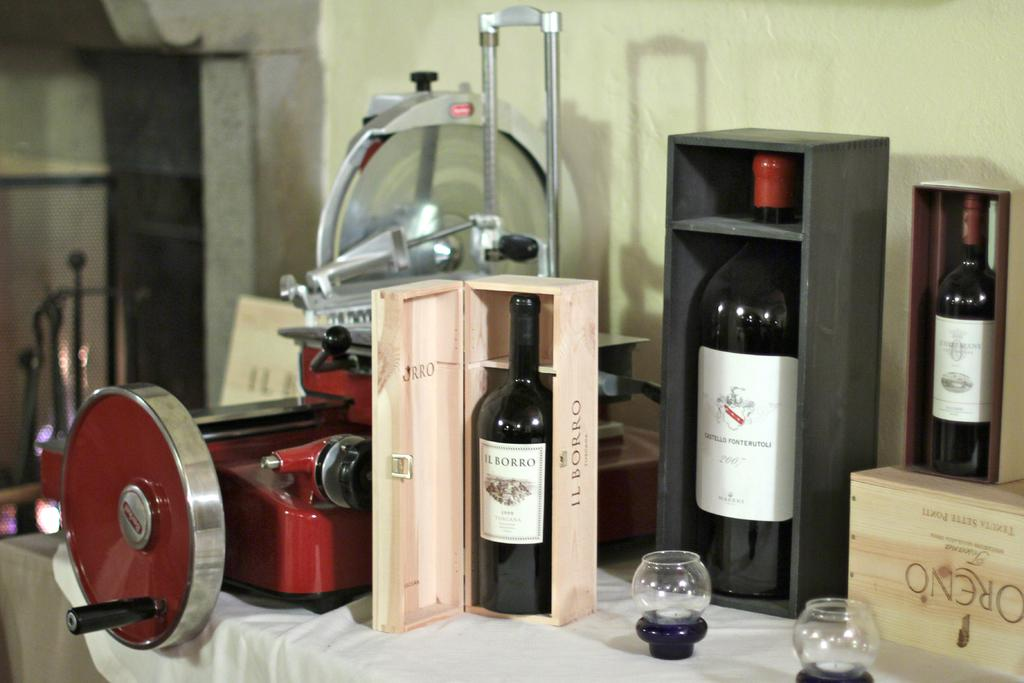<image>
Summarize the visual content of the image. A bottle of Ilborro wine is in a wooden box on a table. 